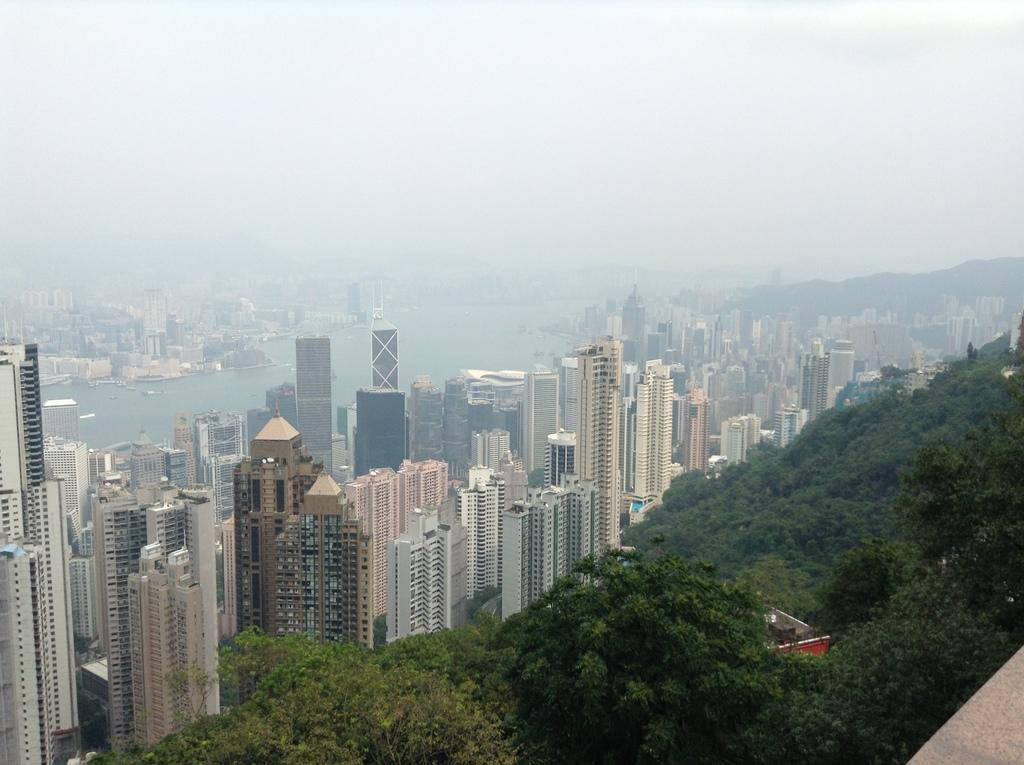What type of natural elements can be seen in the image? There are trees in the image. What type of man-made structures are present in the image? There are buildings in the image. What body of water is visible in the image? There is a lake in the middle of the buildings. What can be seen in the background of the image? The sky is visible in the background of the image. Where is the dock located in the image? There is no dock present in the image. What type of development is happening at the edge of the lake in the image? There is no development or construction activity visible at the edge of the lake in the image. 